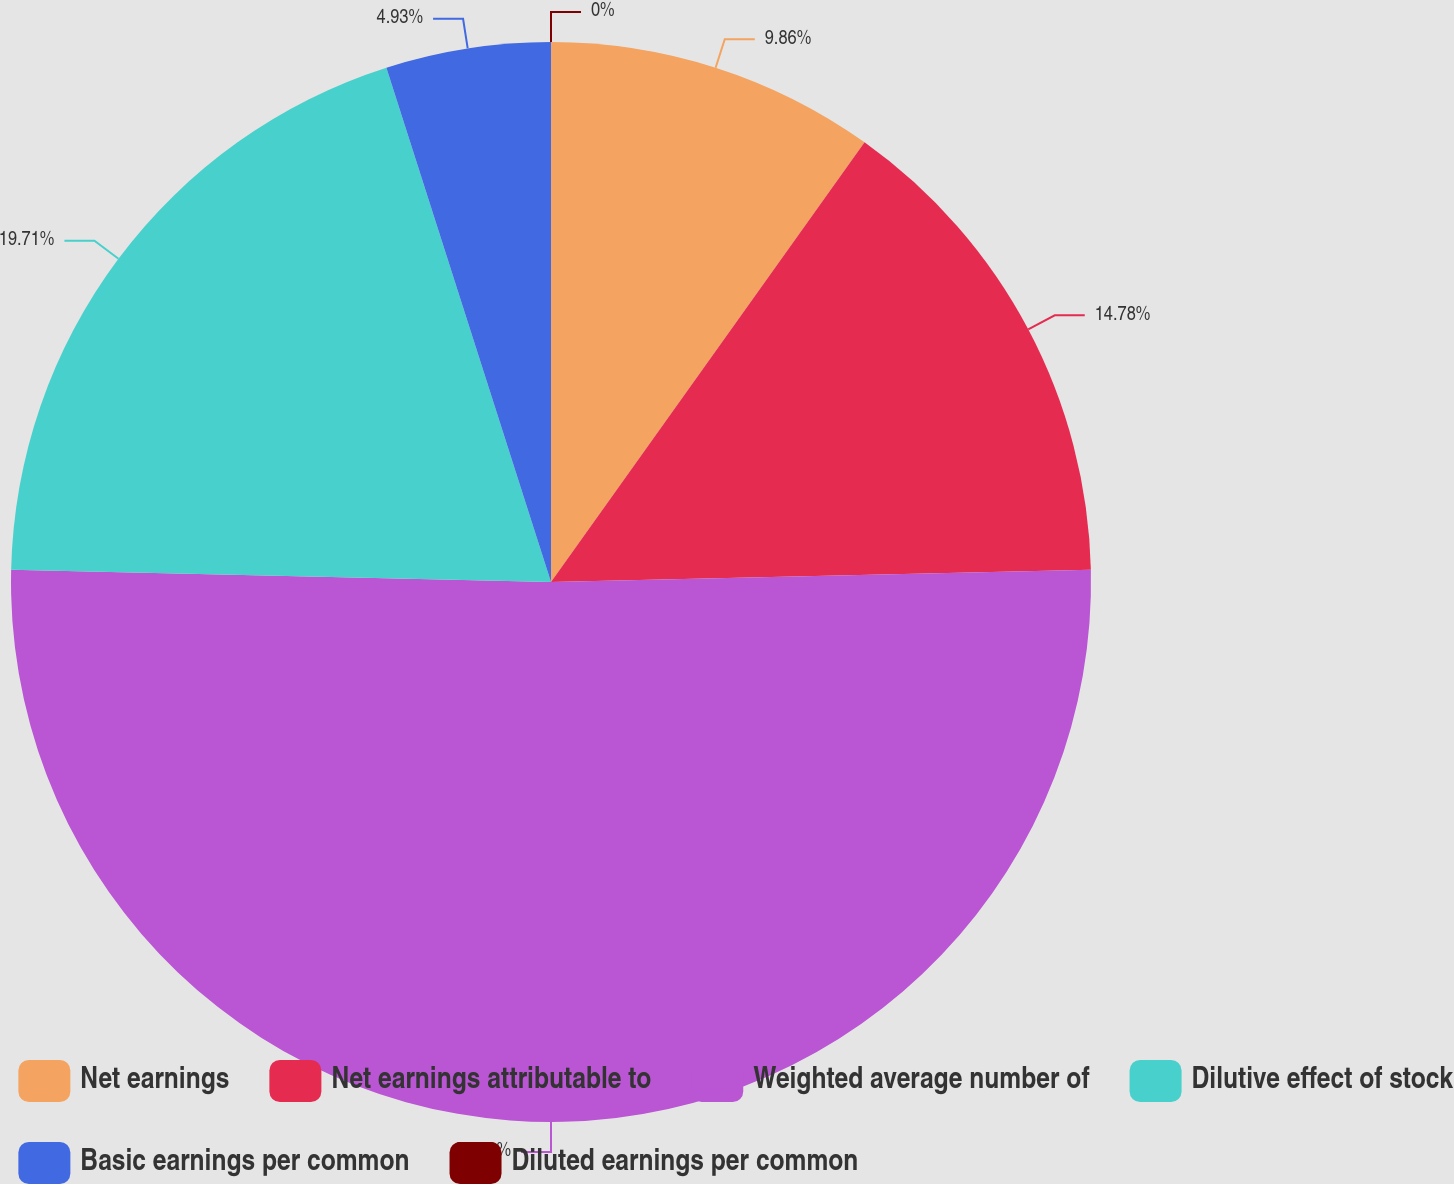Convert chart to OTSL. <chart><loc_0><loc_0><loc_500><loc_500><pie_chart><fcel>Net earnings<fcel>Net earnings attributable to<fcel>Weighted average number of<fcel>Dilutive effect of stock<fcel>Basic earnings per common<fcel>Diluted earnings per common<nl><fcel>9.86%<fcel>14.78%<fcel>50.72%<fcel>19.71%<fcel>4.93%<fcel>0.0%<nl></chart> 